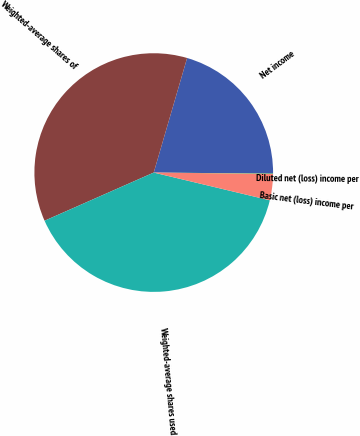<chart> <loc_0><loc_0><loc_500><loc_500><pie_chart><fcel>Net income<fcel>Weighted-average shares of<fcel>Weighted-average shares used<fcel>Basic net (loss) income per<fcel>Diluted net (loss) income per<nl><fcel>20.63%<fcel>36.12%<fcel>39.65%<fcel>3.56%<fcel>0.03%<nl></chart> 